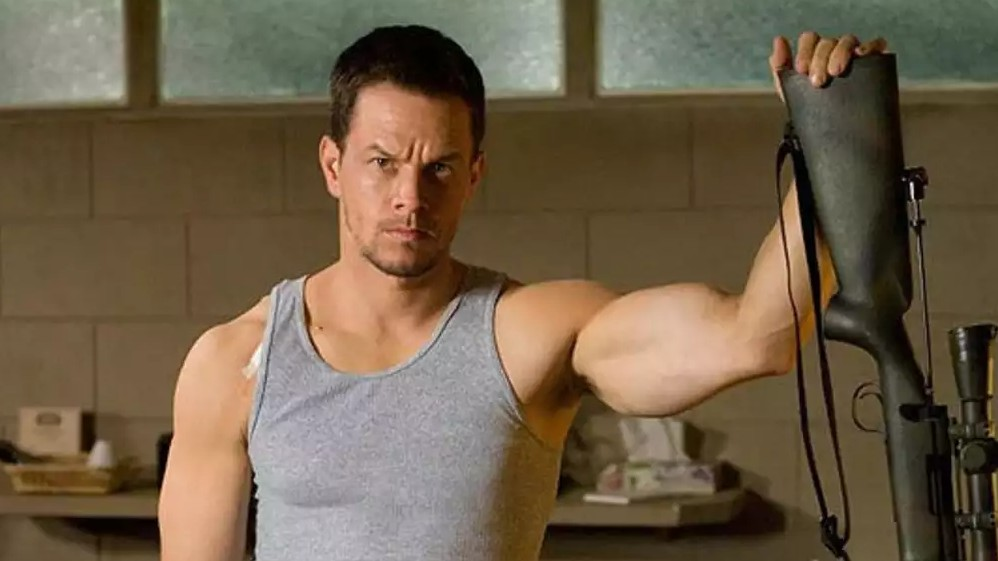Can you tell more about the setting of this scene? The room has a simplistic and functional design, probably indicating a space used for practical purposes such as storage or maintenance tasks. The light through the window suggests daytime, and the lack of decorative elements emphasizes the room's utilitarian use. This backdrop could imply that the character is in a setting related to work or craft, such as a workshop or garage. 